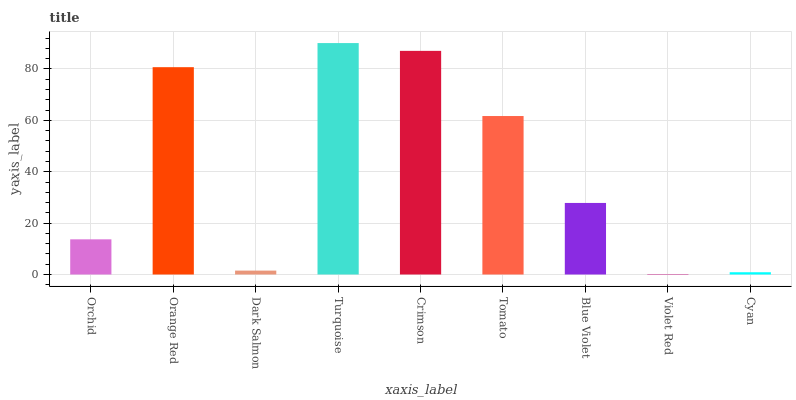Is Violet Red the minimum?
Answer yes or no. Yes. Is Turquoise the maximum?
Answer yes or no. Yes. Is Orange Red the minimum?
Answer yes or no. No. Is Orange Red the maximum?
Answer yes or no. No. Is Orange Red greater than Orchid?
Answer yes or no. Yes. Is Orchid less than Orange Red?
Answer yes or no. Yes. Is Orchid greater than Orange Red?
Answer yes or no. No. Is Orange Red less than Orchid?
Answer yes or no. No. Is Blue Violet the high median?
Answer yes or no. Yes. Is Blue Violet the low median?
Answer yes or no. Yes. Is Crimson the high median?
Answer yes or no. No. Is Violet Red the low median?
Answer yes or no. No. 